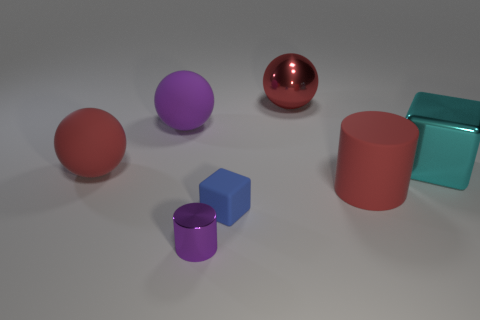There is another thing that is the same size as the blue thing; what is it made of?
Keep it short and to the point. Metal. There is a thing that is in front of the big red matte cylinder and behind the small purple shiny cylinder; what material is it made of?
Your response must be concise. Rubber. There is a purple thing behind the tiny purple cylinder; are there any big red things that are on the right side of it?
Your answer should be very brief. Yes. There is a shiny object that is both in front of the red metallic sphere and behind the blue rubber block; how big is it?
Your response must be concise. Large. How many gray things are matte cubes or blocks?
Give a very brief answer. 0. There is a red shiny object that is the same size as the red cylinder; what shape is it?
Provide a succinct answer. Sphere. What number of other things are the same color as the large shiny block?
Provide a succinct answer. 0. What size is the red thing that is on the left side of the tiny thing that is to the right of the tiny purple cylinder?
Give a very brief answer. Large. Does the block that is on the right side of the large red cylinder have the same material as the tiny purple cylinder?
Offer a very short reply. Yes. There is a purple object that is behind the small cylinder; what is its shape?
Provide a succinct answer. Sphere. 